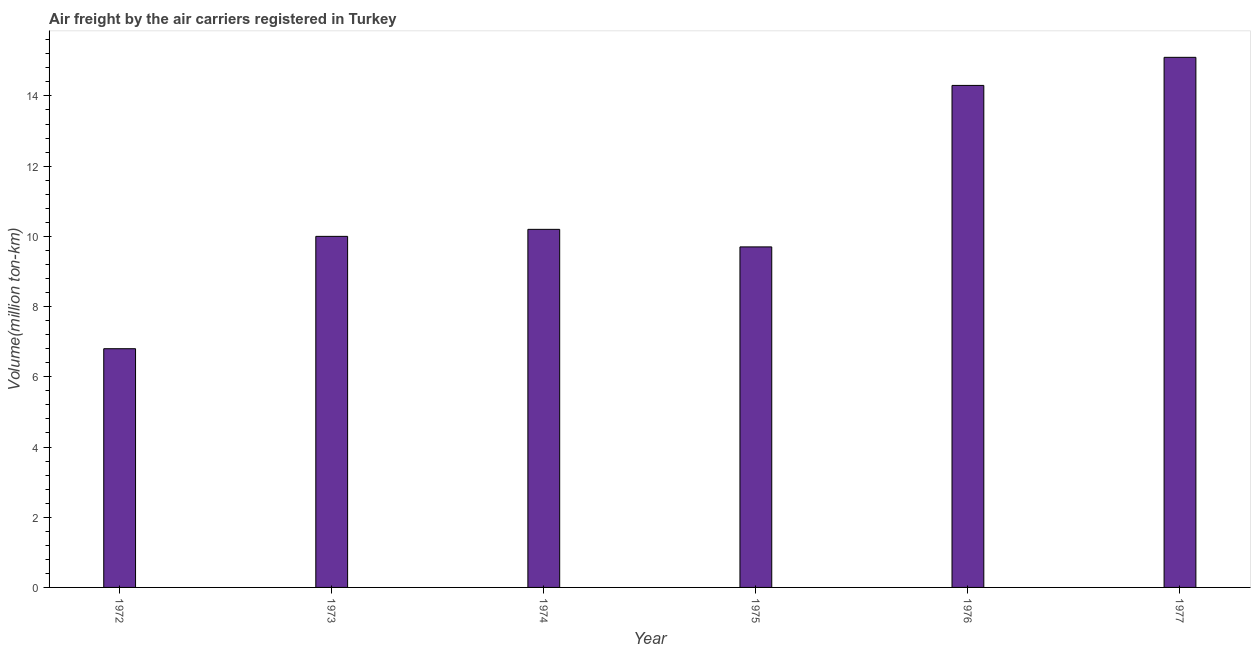Does the graph contain any zero values?
Offer a very short reply. No. What is the title of the graph?
Make the answer very short. Air freight by the air carriers registered in Turkey. What is the label or title of the Y-axis?
Ensure brevity in your answer.  Volume(million ton-km). What is the air freight in 1972?
Provide a short and direct response. 6.8. Across all years, what is the maximum air freight?
Make the answer very short. 15.1. Across all years, what is the minimum air freight?
Provide a short and direct response. 6.8. In which year was the air freight minimum?
Keep it short and to the point. 1972. What is the sum of the air freight?
Give a very brief answer. 66.1. What is the average air freight per year?
Make the answer very short. 11.02. What is the median air freight?
Your response must be concise. 10.1. In how many years, is the air freight greater than 12 million ton-km?
Your answer should be compact. 2. Do a majority of the years between 1977 and 1974 (inclusive) have air freight greater than 7.6 million ton-km?
Offer a very short reply. Yes. What is the ratio of the air freight in 1973 to that in 1976?
Ensure brevity in your answer.  0.7. Is the difference between the air freight in 1974 and 1975 greater than the difference between any two years?
Offer a terse response. No. What is the difference between the highest and the second highest air freight?
Give a very brief answer. 0.8. What is the difference between the highest and the lowest air freight?
Your answer should be very brief. 8.3. In how many years, is the air freight greater than the average air freight taken over all years?
Your answer should be compact. 2. How many bars are there?
Ensure brevity in your answer.  6. How many years are there in the graph?
Keep it short and to the point. 6. What is the difference between two consecutive major ticks on the Y-axis?
Ensure brevity in your answer.  2. Are the values on the major ticks of Y-axis written in scientific E-notation?
Provide a succinct answer. No. What is the Volume(million ton-km) of 1972?
Your answer should be compact. 6.8. What is the Volume(million ton-km) of 1974?
Your response must be concise. 10.2. What is the Volume(million ton-km) of 1975?
Offer a terse response. 9.7. What is the Volume(million ton-km) in 1976?
Provide a succinct answer. 14.3. What is the Volume(million ton-km) of 1977?
Ensure brevity in your answer.  15.1. What is the difference between the Volume(million ton-km) in 1972 and 1973?
Your answer should be very brief. -3.2. What is the difference between the Volume(million ton-km) in 1972 and 1974?
Offer a very short reply. -3.4. What is the difference between the Volume(million ton-km) in 1972 and 1975?
Offer a terse response. -2.9. What is the difference between the Volume(million ton-km) in 1972 and 1976?
Give a very brief answer. -7.5. What is the difference between the Volume(million ton-km) in 1972 and 1977?
Make the answer very short. -8.3. What is the difference between the Volume(million ton-km) in 1973 and 1974?
Your response must be concise. -0.2. What is the difference between the Volume(million ton-km) in 1974 and 1975?
Offer a terse response. 0.5. What is the difference between the Volume(million ton-km) in 1975 and 1976?
Your response must be concise. -4.6. What is the difference between the Volume(million ton-km) in 1976 and 1977?
Give a very brief answer. -0.8. What is the ratio of the Volume(million ton-km) in 1972 to that in 1973?
Offer a terse response. 0.68. What is the ratio of the Volume(million ton-km) in 1972 to that in 1974?
Provide a succinct answer. 0.67. What is the ratio of the Volume(million ton-km) in 1972 to that in 1975?
Your answer should be compact. 0.7. What is the ratio of the Volume(million ton-km) in 1972 to that in 1976?
Provide a succinct answer. 0.48. What is the ratio of the Volume(million ton-km) in 1972 to that in 1977?
Provide a short and direct response. 0.45. What is the ratio of the Volume(million ton-km) in 1973 to that in 1975?
Provide a succinct answer. 1.03. What is the ratio of the Volume(million ton-km) in 1973 to that in 1976?
Provide a short and direct response. 0.7. What is the ratio of the Volume(million ton-km) in 1973 to that in 1977?
Offer a very short reply. 0.66. What is the ratio of the Volume(million ton-km) in 1974 to that in 1975?
Make the answer very short. 1.05. What is the ratio of the Volume(million ton-km) in 1974 to that in 1976?
Give a very brief answer. 0.71. What is the ratio of the Volume(million ton-km) in 1974 to that in 1977?
Give a very brief answer. 0.68. What is the ratio of the Volume(million ton-km) in 1975 to that in 1976?
Make the answer very short. 0.68. What is the ratio of the Volume(million ton-km) in 1975 to that in 1977?
Your answer should be compact. 0.64. What is the ratio of the Volume(million ton-km) in 1976 to that in 1977?
Your response must be concise. 0.95. 